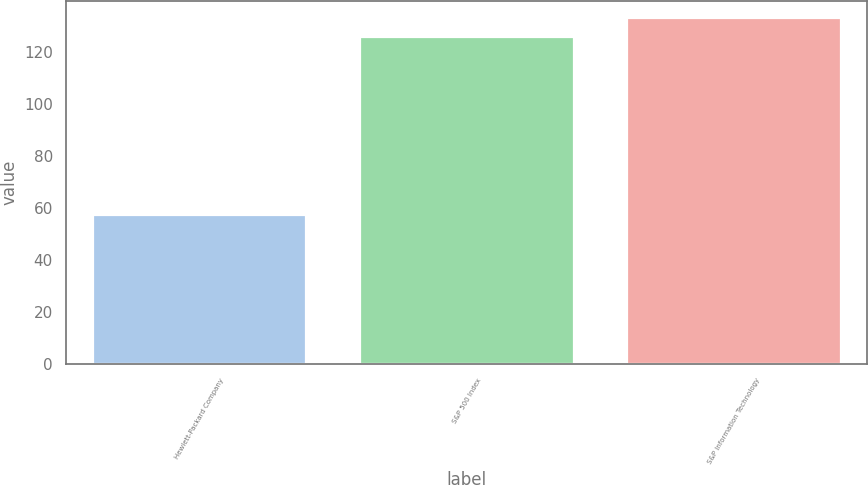Convert chart to OTSL. <chart><loc_0><loc_0><loc_500><loc_500><bar_chart><fcel>Hewlett-Packard Company<fcel>S&P 500 Index<fcel>S&P Information Technology<nl><fcel>57.17<fcel>125.93<fcel>133.07<nl></chart> 